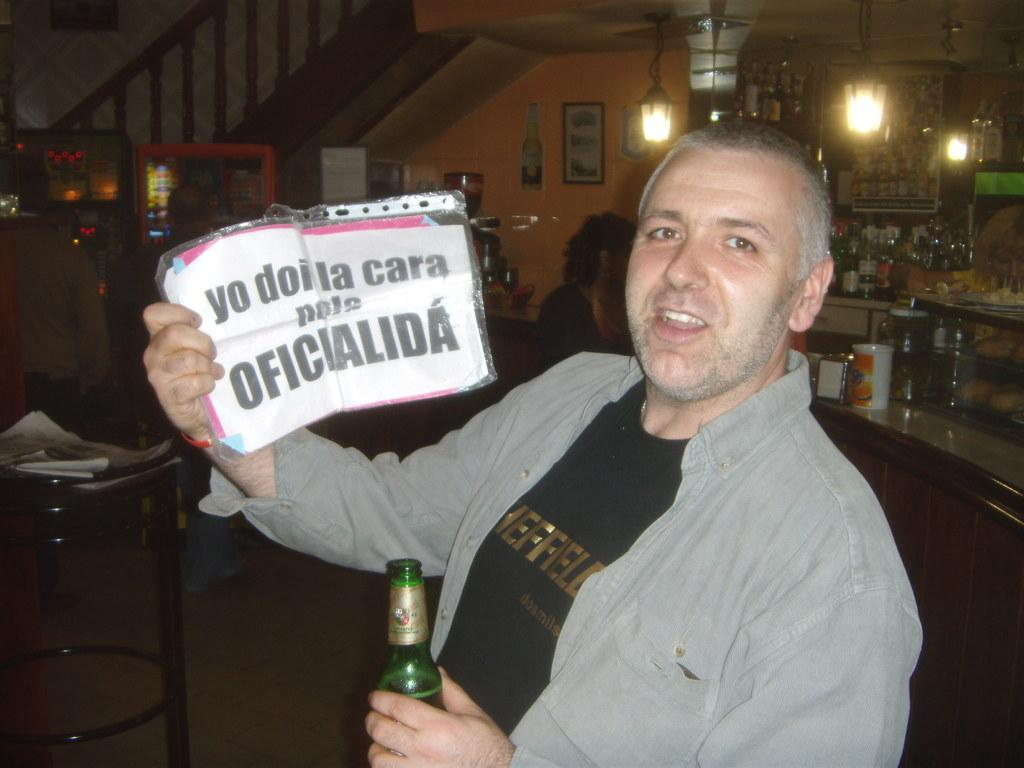Who is present in the image? There is a man in the image. What is the man holding in his hand? The man is holding a bottle and a placard. Where does the scene take place? The scene takes place in a home. What type of vegetable is the man using to shock his dad in the image? There is no vegetable or shocking activity present in the image. 